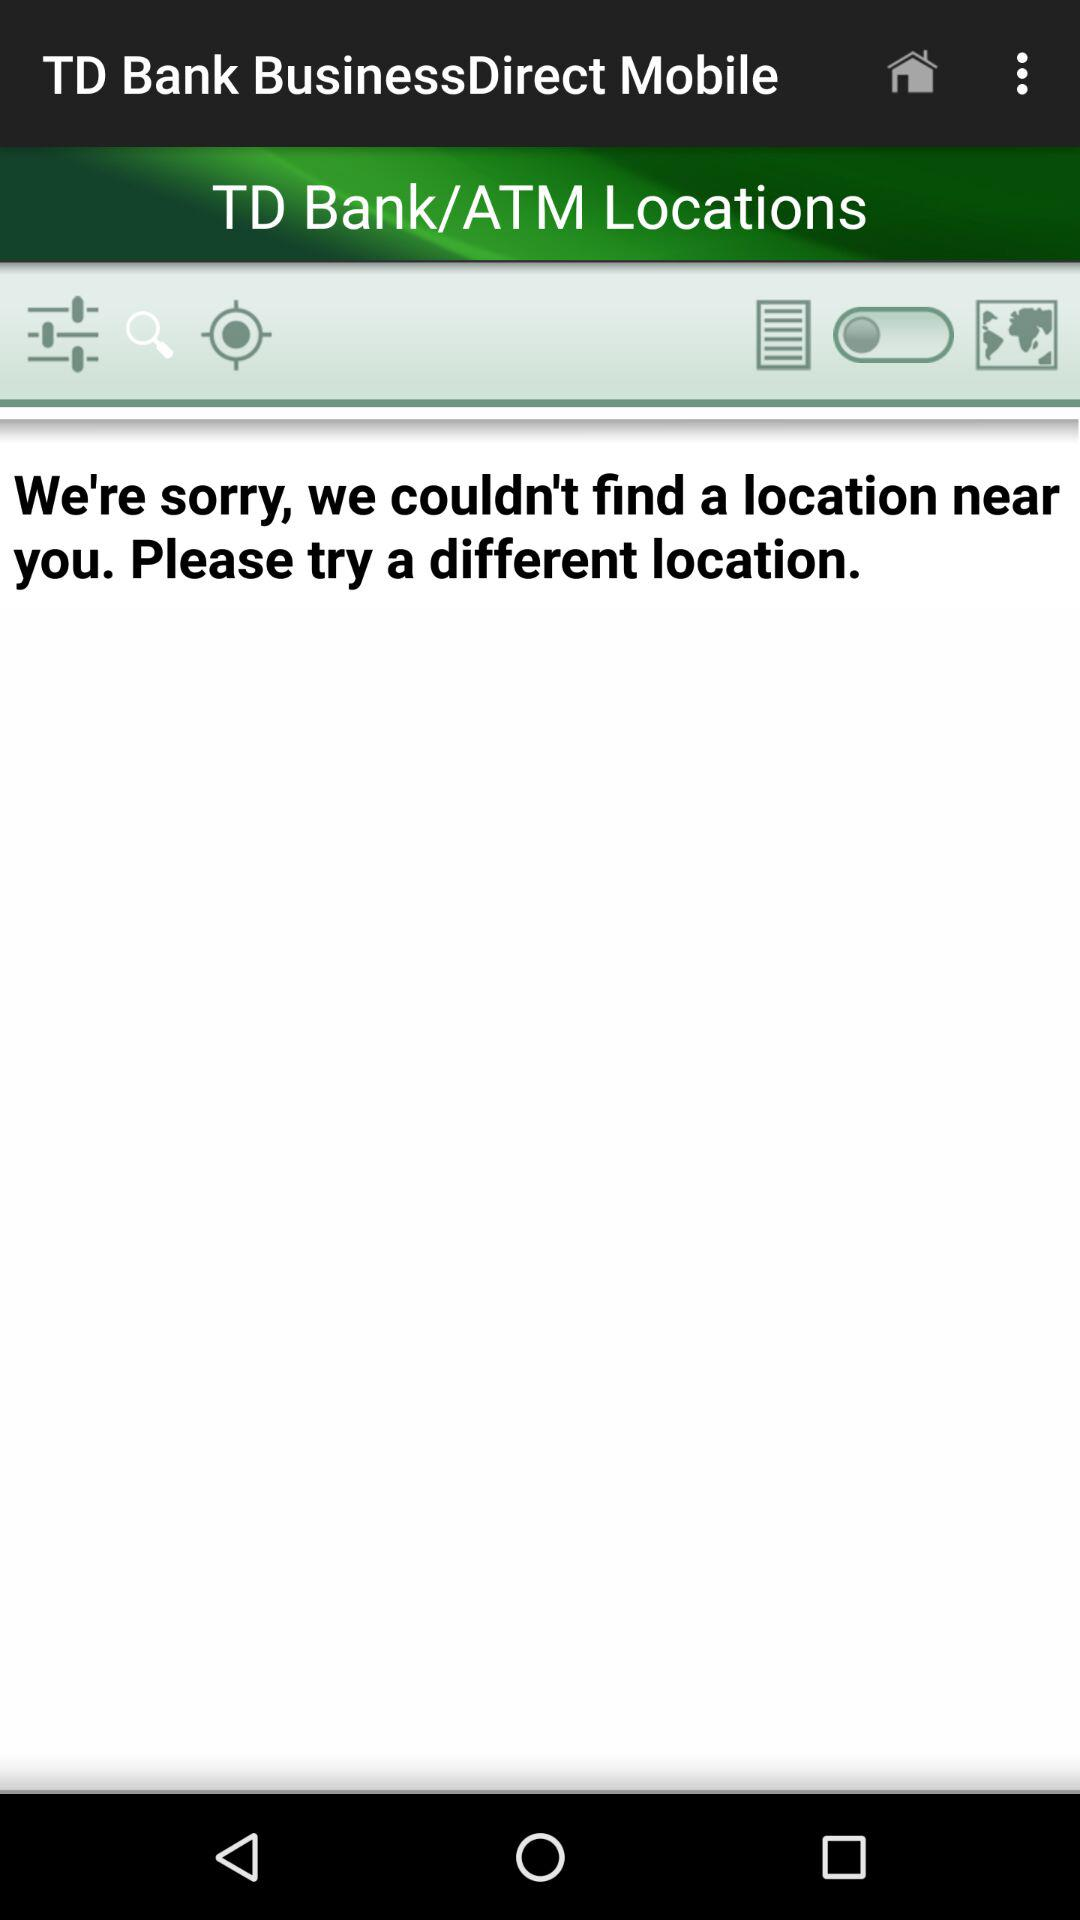What is the name of the application? The name of the application is "TD Bank BusinessDirect Mobile". 